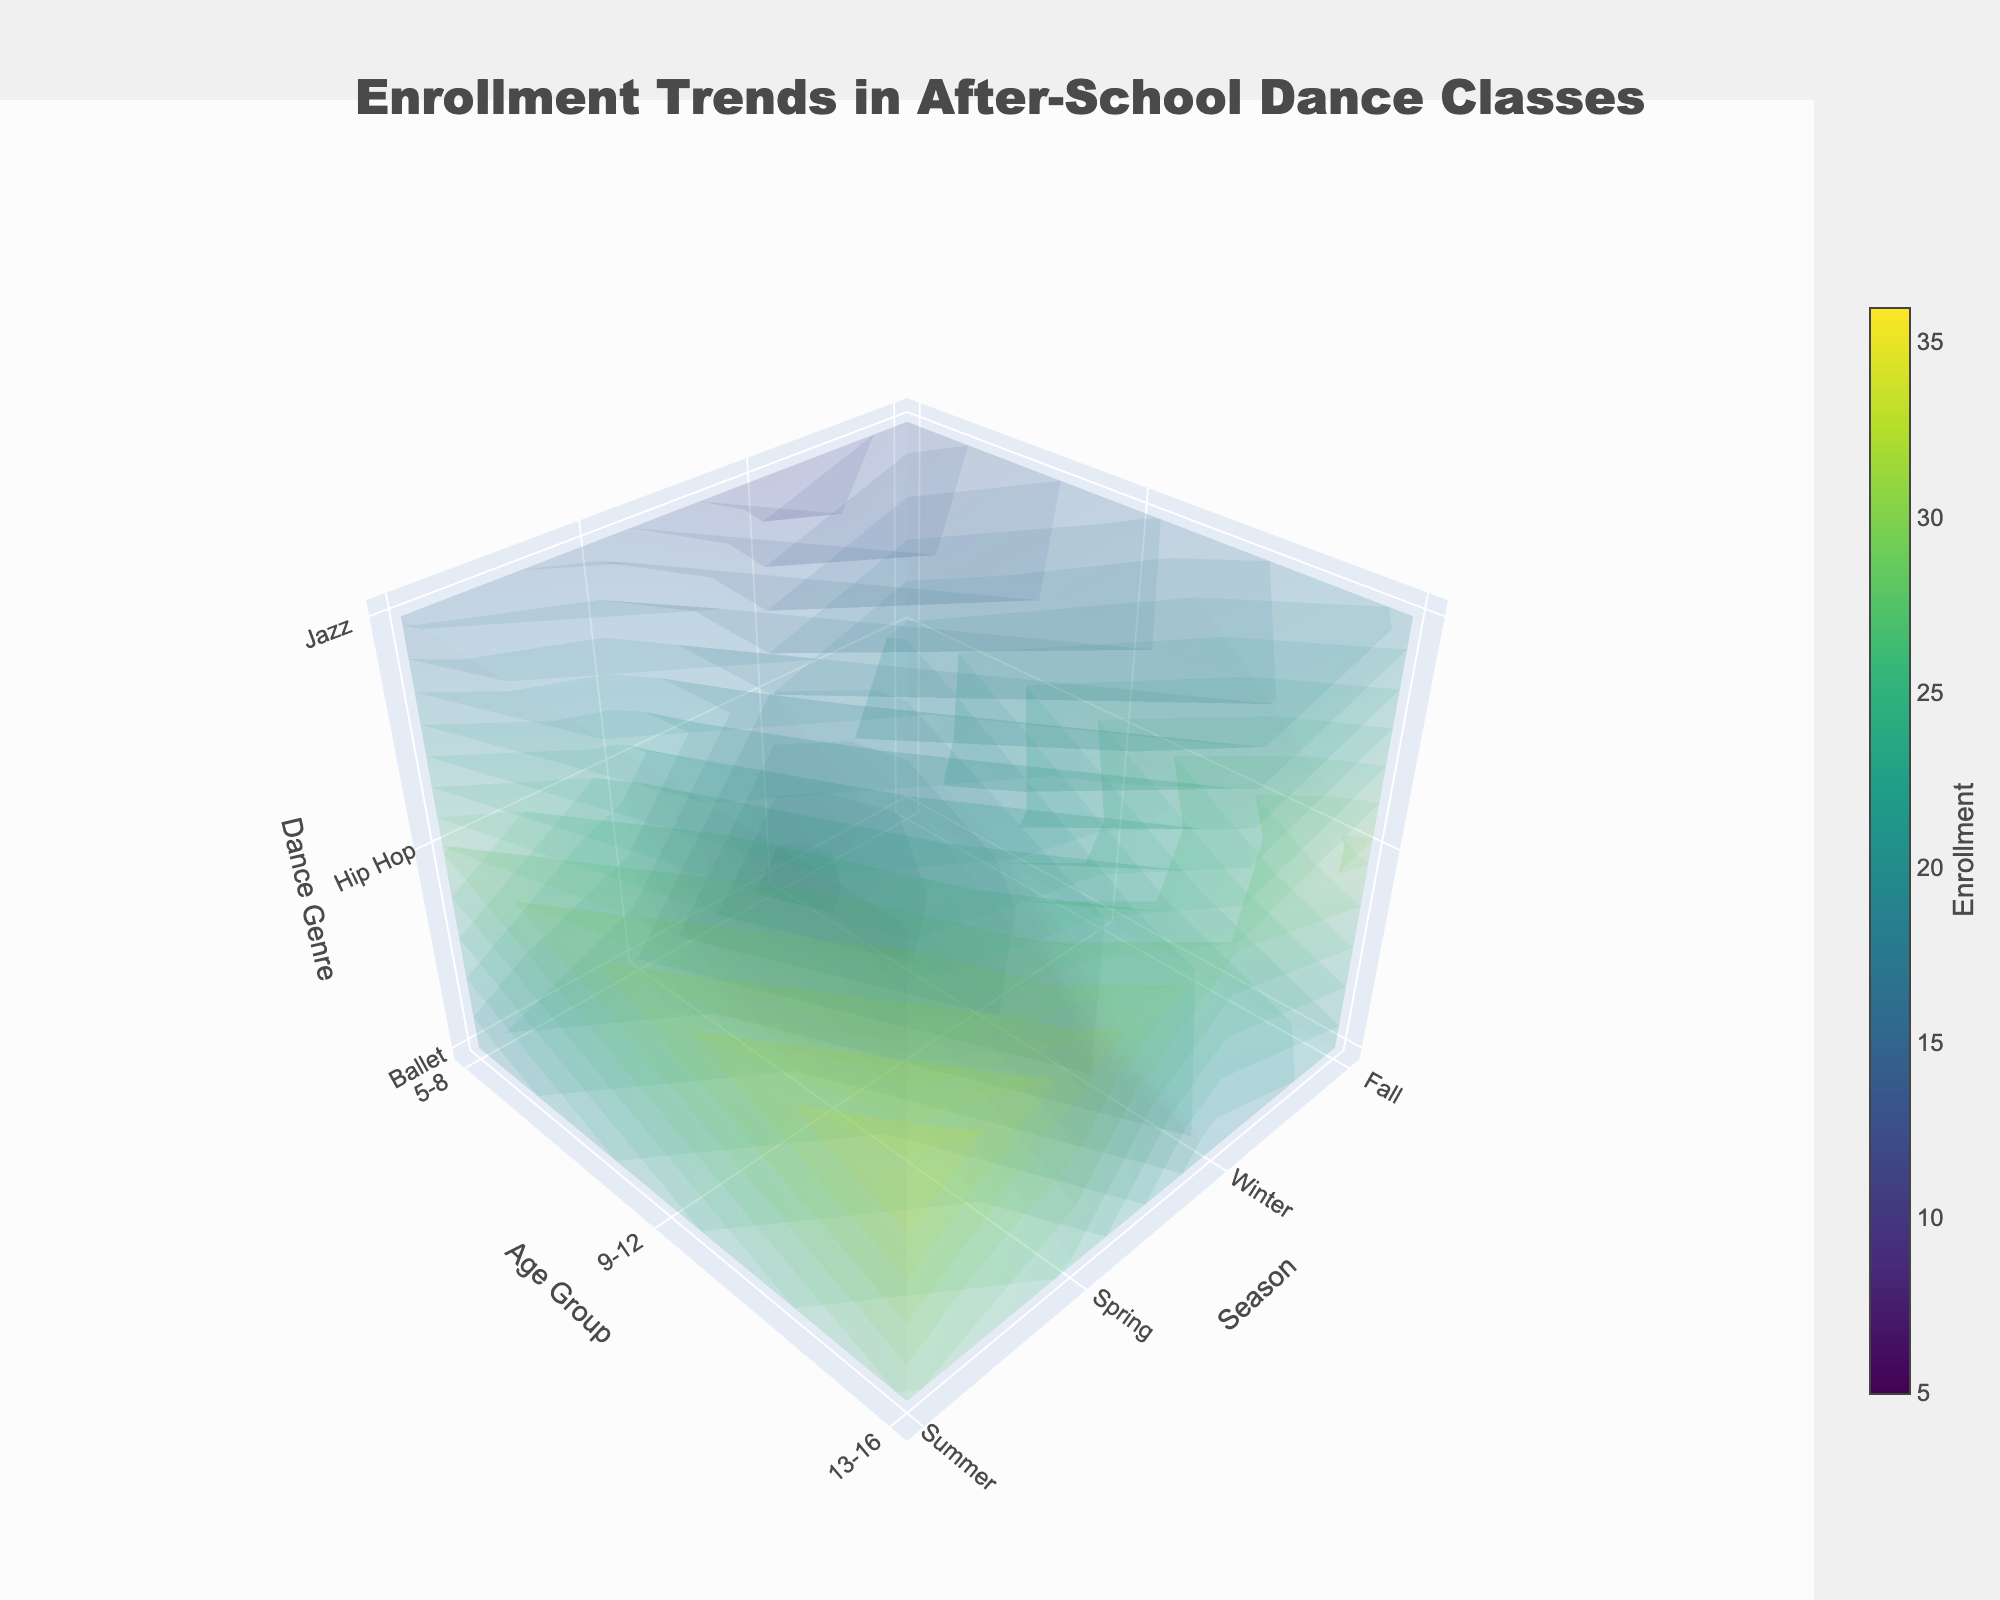What is the title of the 3D volume plot? The title is located at the top of the plot. It provides an overview of what the plot represents.
Answer: Enrollment Trends in After-School Dance Classes What are the three axes in the plot, and what do they represent? The three axes are marked with titles that indicate their respective variables.
Answer: Season, Age Group, Dance Genre Which season shows the highest enrollment in Ballet for ages 5-8? To determine the highest enrollment, check the values corresponding to Ballet for ages 5-8 across all seasons.
Answer: Summer What is the trend for Hip Hop enrollment for ages 13-16 across different seasons? Observe the changes in the values on the plot for Hip Hop in the 13-16 age group as one moves from Fall to Summer.
Answer: Increasing Compare the total Jazz enrollment for ages 9-12 in Winter and Summer. Which season has higher enrollment? Sum the enrollment numbers for Jazz in the 9-12 age group for Winter and Summer, then compare them. Winter: 14, Summer: 20.
Answer: Summer Which dance genre has the lowest enrollment in Spring for ages 5-8? For Spring and ages 5-8, compare the values for Ballet, Hip Hop, and Jazz to see which is lowest.
Answer: Jazz What is the average enrollment for Ballet across all age groups in Fall? Sum the enrollment numbers for Ballet in Fall across all age groups and divide by the number of age groups. (15+18+22)/3 = 55/3
Answer: 18.33 Is there any age group where Jazz enrollment never exceeds 20 across all seasons? Check the enrollment values for Jazz for each age group across all seasons to see if any group never exceeds 20.
Answer: 5-8 What is the maximum enrollment observed in the plot, and for which season, age group, and dance genre is it? Identify the highest value in the plot and note the corresponding season, age group, and dance genre.
Answer: Summer, 13-16, Hip Hop Does the enrollment for Ballet in age group 5-8 show a steady increase across the seasons? Look at the enrollment values for Ballet in age group 5-8 from Fall to Summer to see if they consistently rise. Fall: 15, Winter: 12, Spring: 18, Summer: 20.
Answer: No 